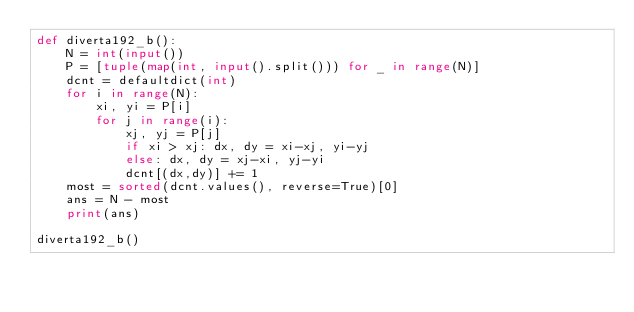Convert code to text. <code><loc_0><loc_0><loc_500><loc_500><_Python_>def diverta192_b():
    N = int(input())
    P = [tuple(map(int, input().split())) for _ in range(N)]
    dcnt = defaultdict(int)
    for i in range(N):
        xi, yi = P[i]
        for j in range(i):
            xj, yj = P[j]
            if xi > xj: dx, dy = xi-xj, yi-yj
            else: dx, dy = xj-xi, yj-yi
            dcnt[(dx,dy)] += 1
    most = sorted(dcnt.values(), reverse=True)[0]
    ans = N - most
    print(ans)

diverta192_b()</code> 